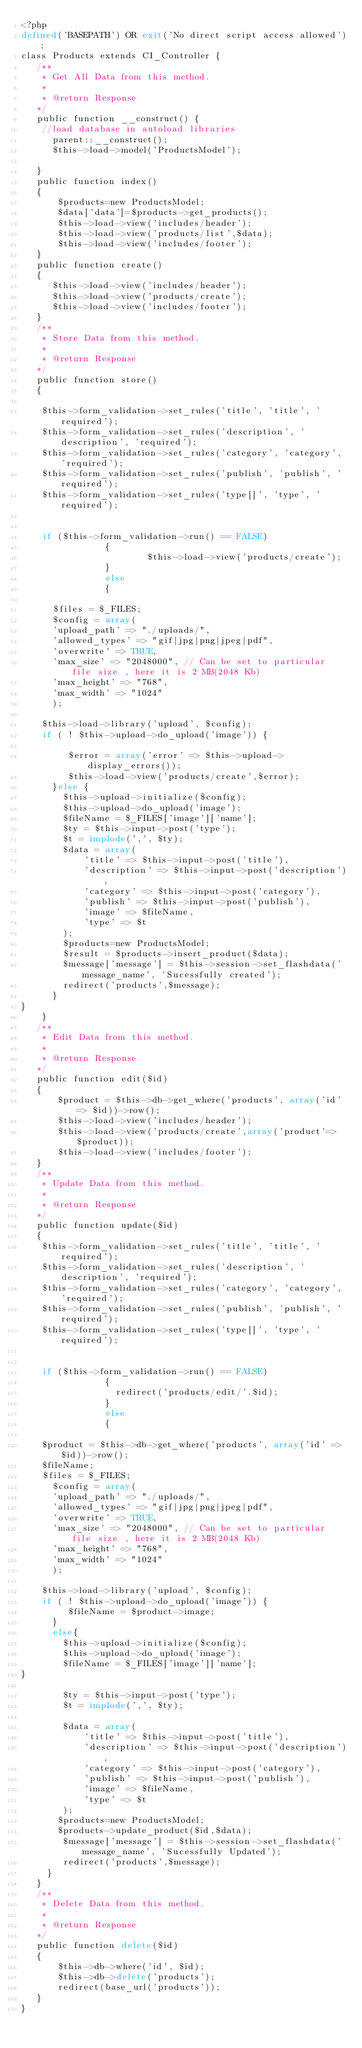Convert code to text. <code><loc_0><loc_0><loc_500><loc_500><_PHP_><?php
defined('BASEPATH') OR exit('No direct script access allowed');
class Products extends CI_Controller {
   /**
    * Get All Data from this method.
    *
    * @return Response
   */
   public function __construct() {
    //load database in autoload libraries 
      parent::__construct(); 
      $this->load->model('ProductsModel');         

   }
   public function index()
   {
       $products=new ProductsModel;
       $data['data']=$products->get_products();
       $this->load->view('includes/header');       
       $this->load->view('products/list',$data);
       $this->load->view('includes/footer');
   }
   public function create()
   {
      $this->load->view('includes/header');
      $this->load->view('products/create');
      $this->load->view('includes/footer');      
   }
   /**
    * Store Data from this method.
    *
    * @return Response
   */
   public function store()
   {

    $this->form_validation->set_rules('title', 'title', 'required');
    $this->form_validation->set_rules('description', 'description', 'required');
    $this->form_validation->set_rules('category', 'category', 'required');
    $this->form_validation->set_rules('publish', 'publish', 'required');
    $this->form_validation->set_rules('type[]', 'type', 'required');


    if ($this->form_validation->run() == FALSE)
                {
                        $this->load->view('products/create');
                }
                else
                {

      $files = $_FILES;  
      $config = array(
      'upload_path' => "./uploads/",
      'allowed_types' => "gif|jpg|png|jpeg|pdf",
      'overwrite' => TRUE,
      'max_size' => "2048000", // Can be set to particular file size , here it is 2 MB(2048 Kb)
      'max_height' => "768",
      'max_width' => "1024"
      );

    $this->load->library('upload', $config);
    if ( ! $this->upload->do_upload('image')) {

         $error = array('error' => $this->upload->display_errors()); 
         $this->load->view('products/create',$error); 
      }else { 
        $this->upload->initialize($config);
        $this->upload->do_upload('image');
        $fileName = $_FILES['image']['name'];
        $ty = $this->input->post('type');
        $t = implode(',', $ty);
        $data = array(
            'title' => $this->input->post('title'),
            'description' => $this->input->post('description'),
            'category' => $this->input->post('category'),
            'publish' => $this->input->post('publish'),
            'image' => $fileName,
            'type' => $t
        );
        $products=new ProductsModel;
        $result = $products->insert_product($data);
        $message['message'] = $this->session->set_flashdata('message_name', 'Sucessfully created');
        redirect('products',$message);   
      }
}
    }
   /**
    * Edit Data from this method.
    *
    * @return Response
   */
   public function edit($id)
   {
       $product = $this->db->get_where('products', array('id' => $id))->row();
       $this->load->view('includes/header');
       $this->load->view('products/create',array('product'=>$product));
       $this->load->view('includes/footer');   
   }
   /**
    * Update Data from this method.
    *
    * @return Response
   */
   public function update($id)
   {
    $this->form_validation->set_rules('title', 'title', 'required');
    $this->form_validation->set_rules('description', 'description', 'required');
    $this->form_validation->set_rules('category', 'category', 'required');
    $this->form_validation->set_rules('publish', 'publish', 'required');
    $this->form_validation->set_rules('type[]', 'type', 'required');


    if ($this->form_validation->run() == FALSE)
                {
                  redirect('products/edit/'.$id);   
                }
                else
                {

    $product = $this->db->get_where('products', array('id' => $id))->row();
    $fileName;
    $files = $_FILES;  
      $config = array(
      'upload_path' => "./uploads/",
      'allowed_types' => "gif|jpg|png|jpeg|pdf",
      'overwrite' => TRUE,
      'max_size' => "2048000", // Can be set to particular file size , here it is 2 MB(2048 Kb)
      'max_height' => "768",
      'max_width' => "1024"
      );

    $this->load->library('upload', $config);
    if ( ! $this->upload->do_upload('image')) {
         $fileName = $product->image;
      }
      else{
        $this->upload->initialize($config);
        $this->upload->do_upload('image');
        $fileName = $_FILES['image']['name'];
}
        
        $ty = $this->input->post('type');
        $t = implode(',', $ty);
        
        $data = array(
            'title' => $this->input->post('title'),
            'description' => $this->input->post('description'),
            'category' => $this->input->post('category'),
            'publish' => $this->input->post('publish'),
            'image' => $fileName,
            'type' => $t
        );
       $products=new ProductsModel;
       $products->update_product($id,$data);
        $message['message'] = $this->session->set_flashdata('message_name', 'Sucessfully Updated');
        redirect('products',$message);   
     }
   }
   /**
    * Delete Data from this method.
    *
    * @return Response
   */
   public function delete($id)
   {
       $this->db->where('id', $id);
       $this->db->delete('products');
       redirect(base_url('products'));
   }
}</code> 